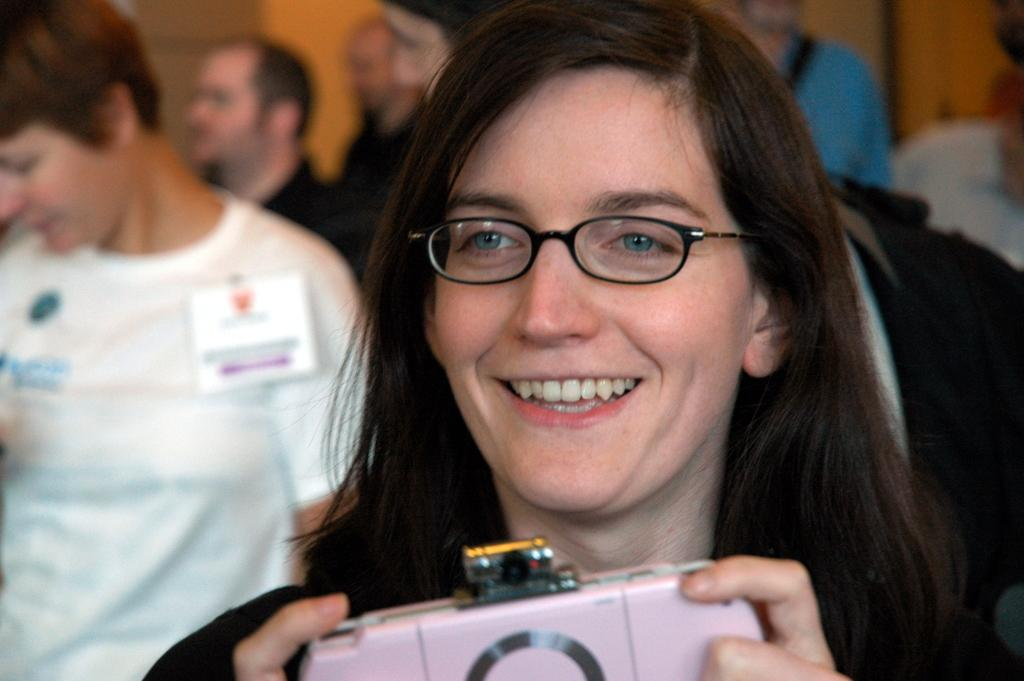Who is the main subject in the image? There is a woman in the image. What is the woman doing in the image? The woman is laughing. What is the woman holding in her hand? The woman is holding a wallet in her hand. Can you describe the people visible behind the woman? There are different persons visible behind the woman. What type of net can be seen in the image? There is no net present in the image. 